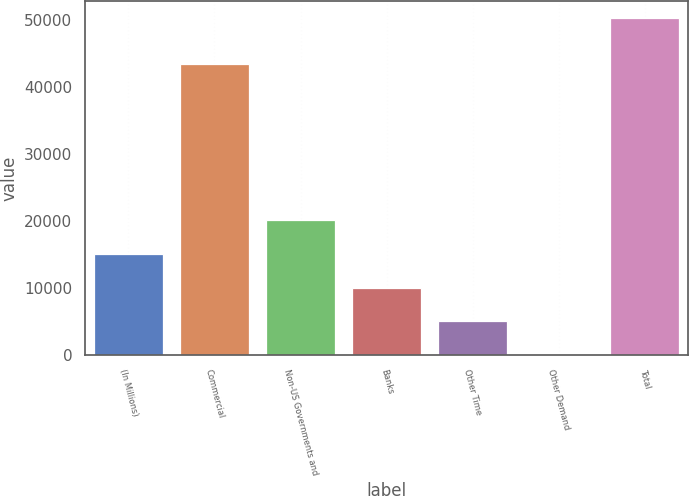Convert chart. <chart><loc_0><loc_0><loc_500><loc_500><bar_chart><fcel>(In Millions)<fcel>Commercial<fcel>Non-US Governments and<fcel>Banks<fcel>Other Time<fcel>Other Demand<fcel>Total<nl><fcel>15085.1<fcel>43466.6<fcel>20111.2<fcel>10058.9<fcel>5032.76<fcel>6.6<fcel>50268.2<nl></chart> 